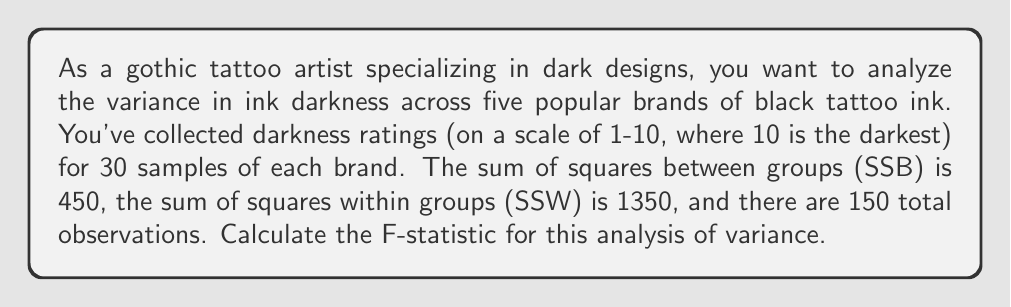Could you help me with this problem? To calculate the F-statistic for this analysis of variance (ANOVA), we need to follow these steps:

1. Identify the components:
   - Number of groups (brands) = 5
   - Total number of observations = 150
   - SSB (Sum of Squares Between groups) = 450
   - SSW (Sum of Squares Within groups) = 1350

2. Calculate the degrees of freedom:
   - df between groups = number of groups - 1 = 5 - 1 = 4
   - df within groups = total observations - number of groups = 150 - 5 = 145
   
3. Calculate the Mean Square Between groups (MSB):
   $$MSB = \frac{SSB}{df_{between}} = \frac{450}{4} = 112.5$$

4. Calculate the Mean Square Within groups (MSW):
   $$MSW = \frac{SSW}{df_{within}} = \frac{1350}{145} \approx 9.31$$

5. Calculate the F-statistic:
   $$F = \frac{MSB}{MSW} = \frac{112.5}{9.31} \approx 12.08$$

The F-statistic is the ratio of the variance between groups to the variance within groups. A larger F-value suggests that there are significant differences between the group means.
Answer: The F-statistic for this analysis of variance is approximately 12.08. 